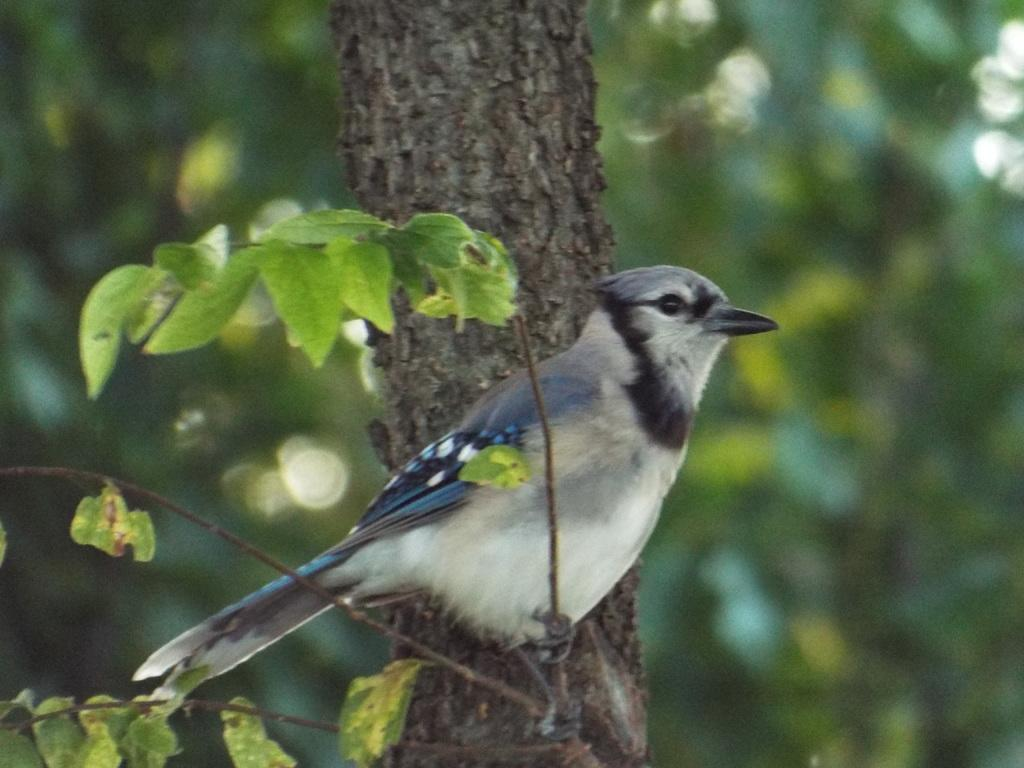What is the main subject of the image? There is a bird standing on a stem in the image. What type of vegetation can be seen in the image? Leaves are visible in the image. What is located in the middle of the image? There is a branch in the middle of the image. What can be seen in the background of the image? There are trees in the background of the image. Where is the vest hanging on the shelf in the image? There is no vest or shelf present in the image; it features a bird standing on a stem with leaves and a branch. Can you tell me how many cherries are on the branch in the image? There are no cherries present on the branch in the image; it only has leaves. 